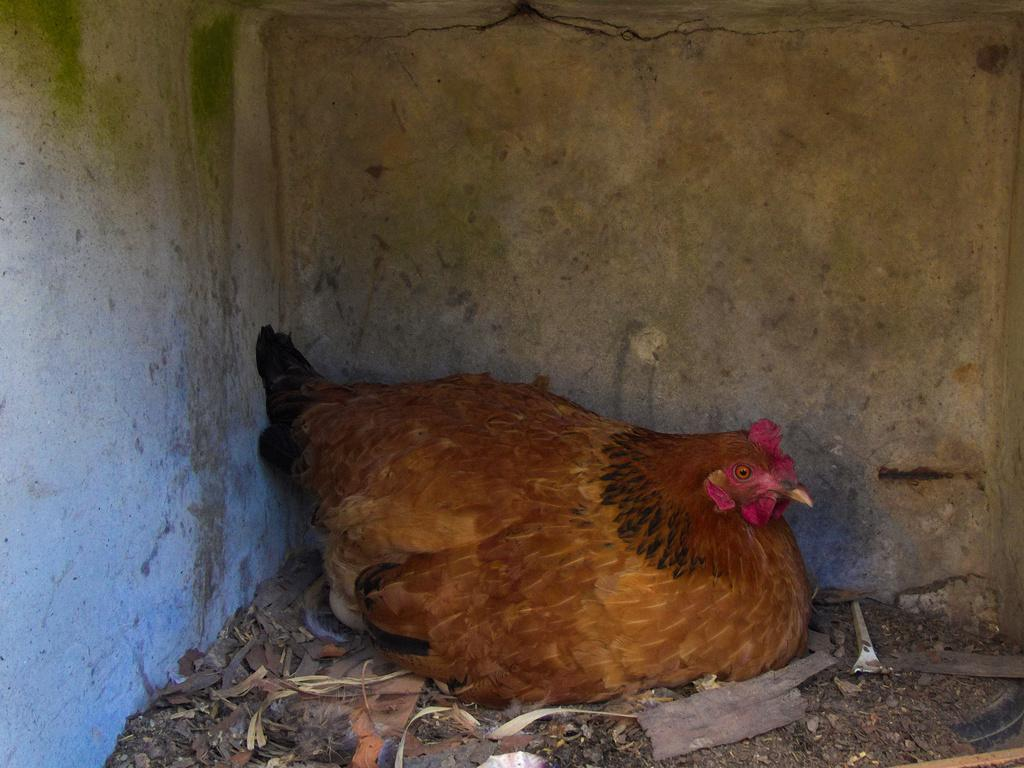What type of animal is in the image? There is a hen in the image. What is the hen standing on? The hen is on a surface in the image. What can be seen in the background of the image? There is a wall in the image. What color is the ink on the window in the image? There is no ink or window present in the image; it only features a hen on a surface with a wall in the background. 